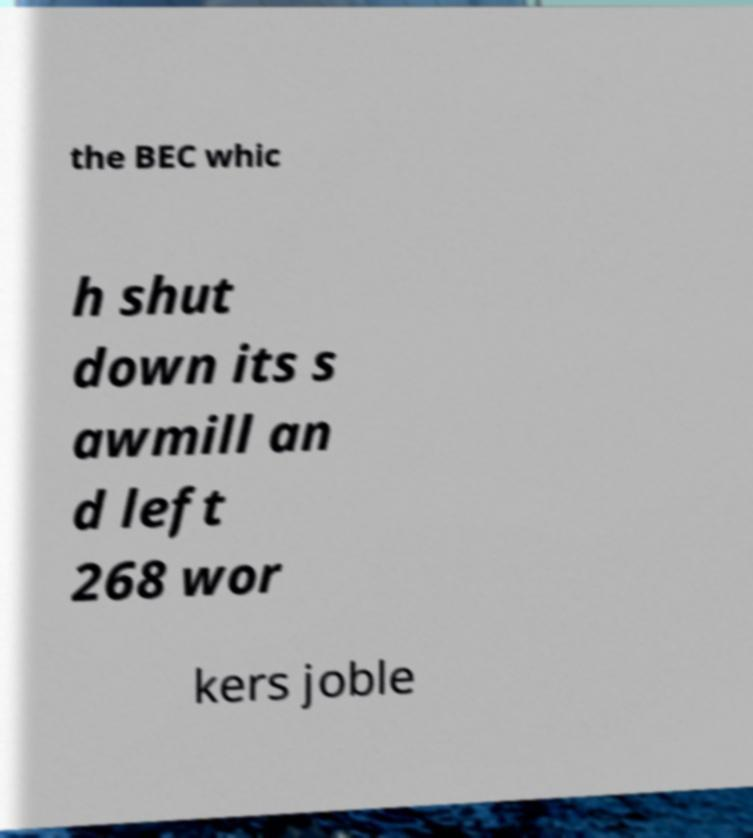Could you extract and type out the text from this image? the BEC whic h shut down its s awmill an d left 268 wor kers joble 